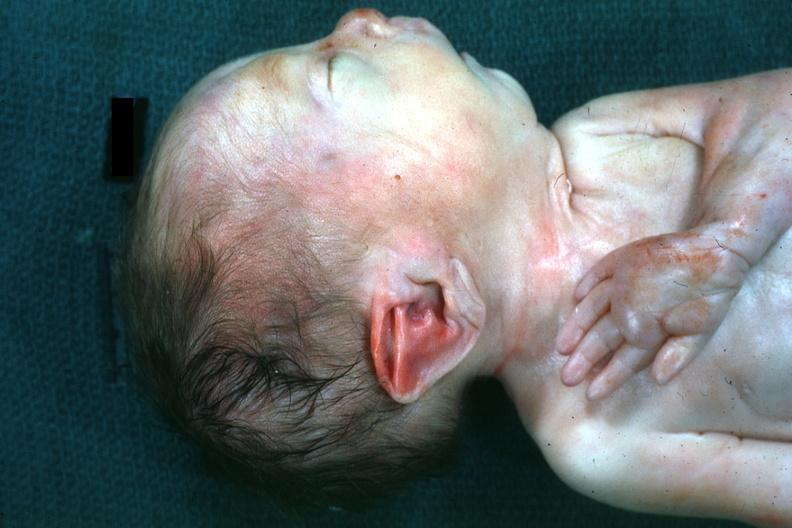s pus in test tube present?
Answer the question using a single word or phrase. No 